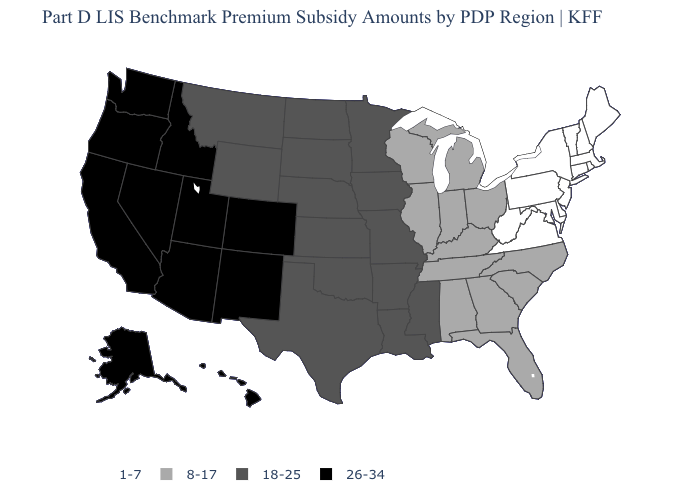Name the states that have a value in the range 26-34?
Write a very short answer. Alaska, Arizona, California, Colorado, Hawaii, Idaho, Nevada, New Mexico, Oregon, Utah, Washington. Name the states that have a value in the range 26-34?
Keep it brief. Alaska, Arizona, California, Colorado, Hawaii, Idaho, Nevada, New Mexico, Oregon, Utah, Washington. Is the legend a continuous bar?
Concise answer only. No. Among the states that border Indiana , which have the lowest value?
Give a very brief answer. Illinois, Kentucky, Michigan, Ohio. What is the value of Wisconsin?
Give a very brief answer. 8-17. What is the value of Missouri?
Write a very short answer. 18-25. What is the highest value in the USA?
Keep it brief. 26-34. Does the map have missing data?
Give a very brief answer. No. How many symbols are there in the legend?
Quick response, please. 4. What is the value of North Dakota?
Concise answer only. 18-25. What is the highest value in the MidWest ?
Be succinct. 18-25. Does Connecticut have a lower value than New York?
Concise answer only. No. Does Hawaii have the highest value in the USA?
Write a very short answer. Yes. What is the lowest value in the South?
Short answer required. 1-7. What is the value of Georgia?
Keep it brief. 8-17. 